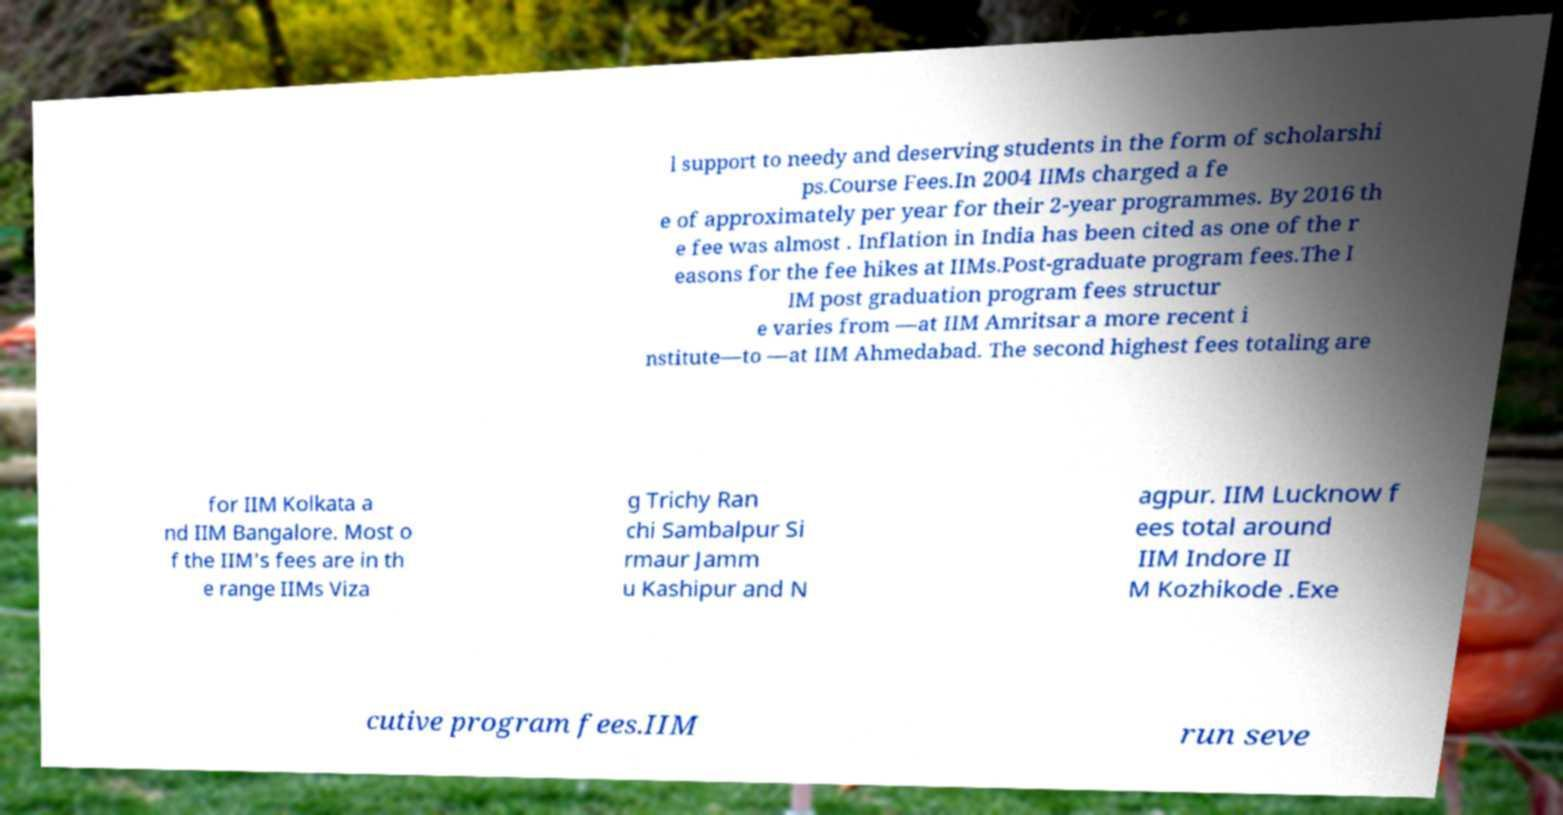Please identify and transcribe the text found in this image. l support to needy and deserving students in the form of scholarshi ps.Course Fees.In 2004 IIMs charged a fe e of approximately per year for their 2-year programmes. By 2016 th e fee was almost . Inflation in India has been cited as one of the r easons for the fee hikes at IIMs.Post-graduate program fees.The I IM post graduation program fees structur e varies from —at IIM Amritsar a more recent i nstitute—to —at IIM Ahmedabad. The second highest fees totaling are for IIM Kolkata a nd IIM Bangalore. Most o f the IIM's fees are in th e range IIMs Viza g Trichy Ran chi Sambalpur Si rmaur Jamm u Kashipur and N agpur. IIM Lucknow f ees total around IIM Indore II M Kozhikode .Exe cutive program fees.IIM run seve 